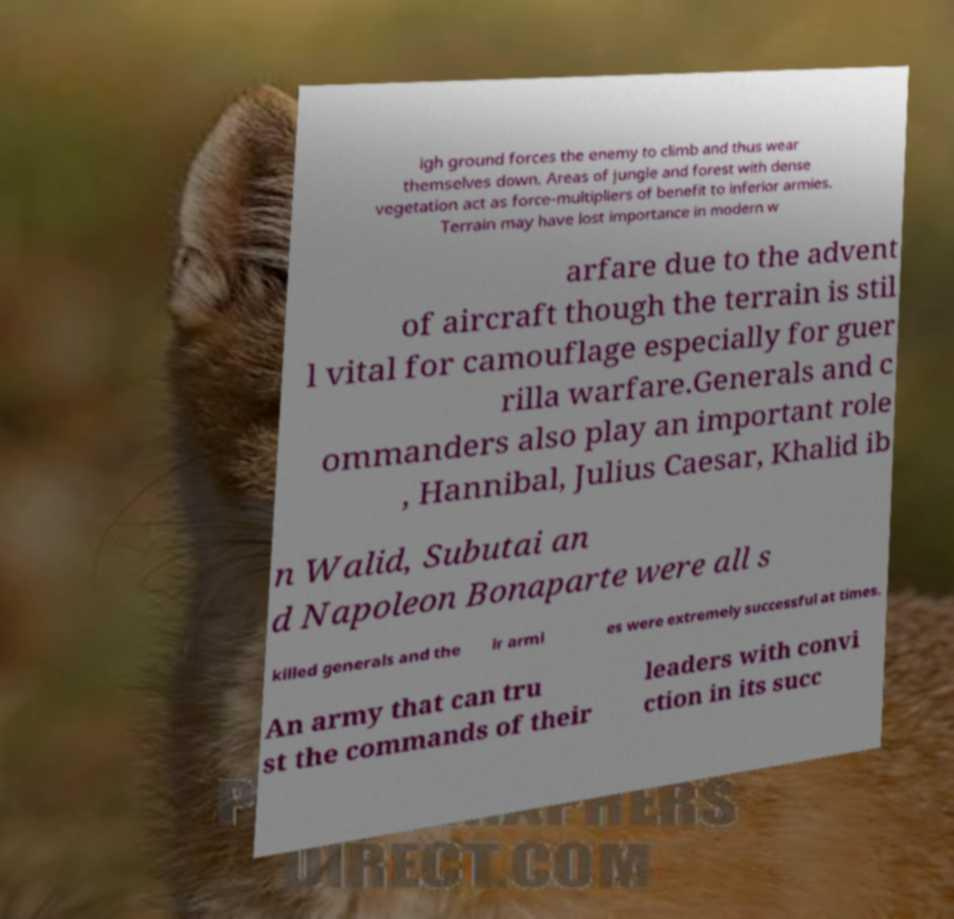There's text embedded in this image that I need extracted. Can you transcribe it verbatim? igh ground forces the enemy to climb and thus wear themselves down. Areas of jungle and forest with dense vegetation act as force-multipliers of benefit to inferior armies. Terrain may have lost importance in modern w arfare due to the advent of aircraft though the terrain is stil l vital for camouflage especially for guer rilla warfare.Generals and c ommanders also play an important role , Hannibal, Julius Caesar, Khalid ib n Walid, Subutai an d Napoleon Bonaparte were all s killed generals and the ir armi es were extremely successful at times. An army that can tru st the commands of their leaders with convi ction in its succ 